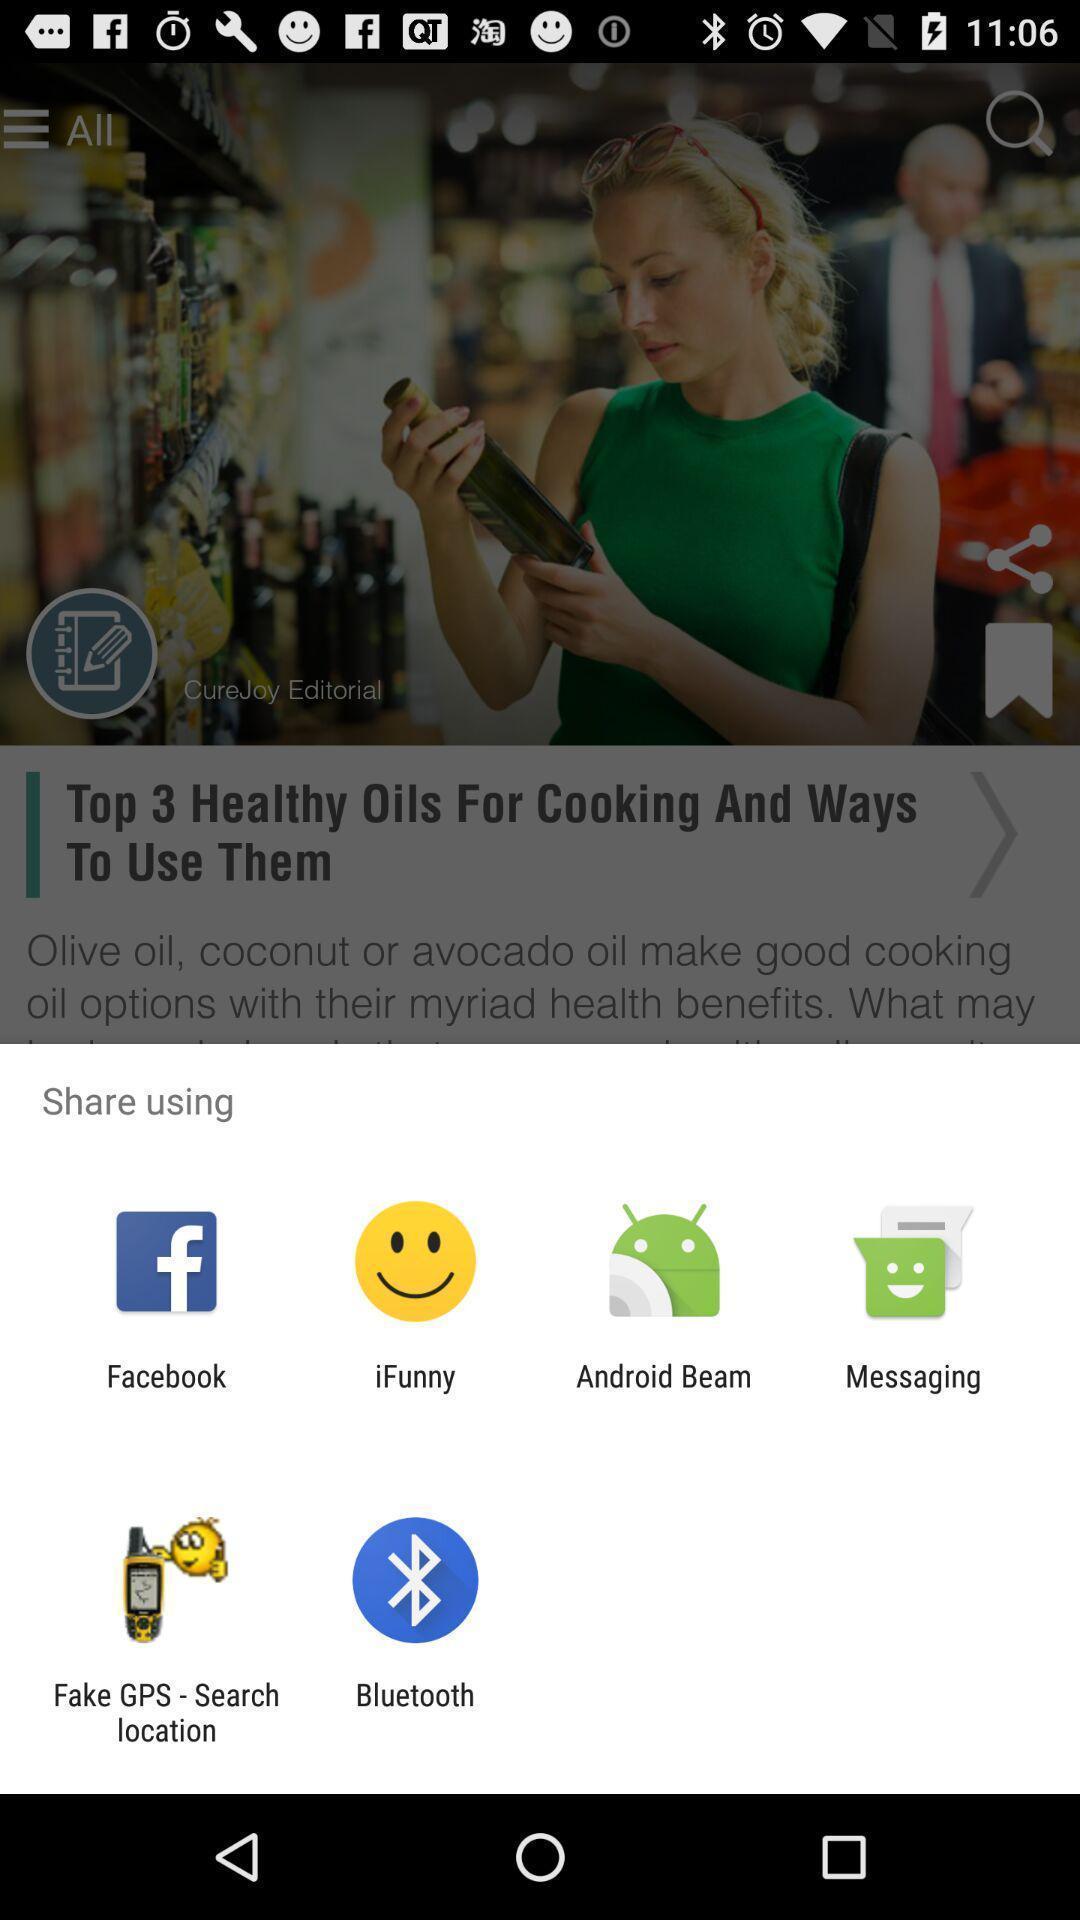Provide a detailed account of this screenshot. Pop-up showing the multiple share options. 